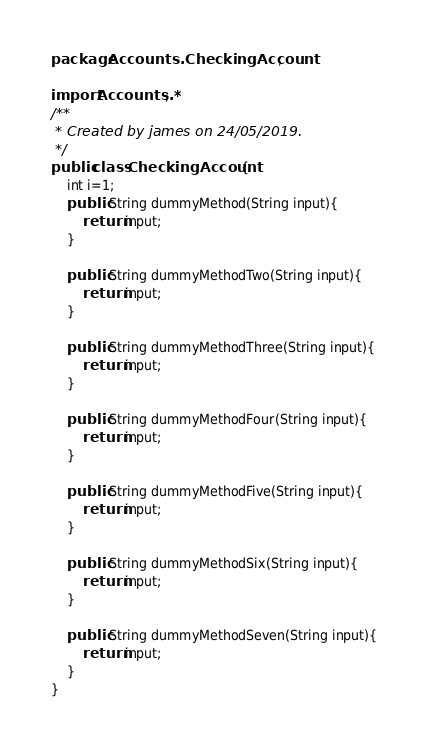<code> <loc_0><loc_0><loc_500><loc_500><_Java_>package Accounts.CheckingAccount;

import Accounts.*;
/**
 * Created by james on 24/05/2019.
 */
public class CheckingAccount {
    int i=1;
    public String dummyMethod(String input){
        return input;
    }

    public String dummyMethodTwo(String input){
        return input;
    }

    public String dummyMethodThree(String input){
        return input;
    }

    public String dummyMethodFour(String input){
        return input;
    }

    public String dummyMethodFive(String input){
        return input;
    }

    public String dummyMethodSix(String input){
        return input;
    }

    public String dummyMethodSeven(String input){
        return input;
    }
}
</code> 